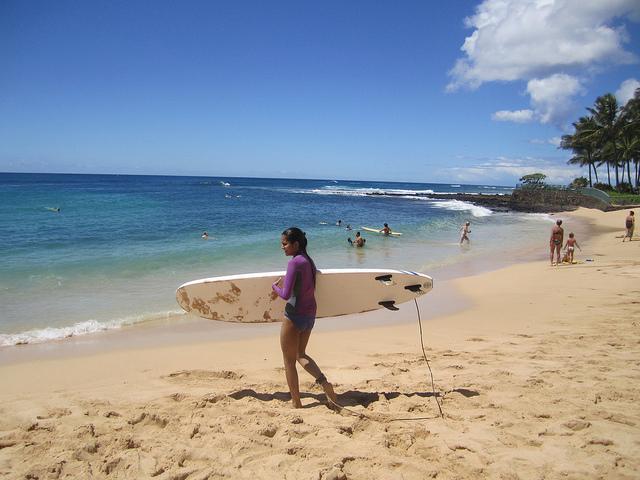Is that a man or a woman?
Be succinct. Woman. Is this an old surfboard?
Write a very short answer. Yes. Is the surfboard strap attached to the surfer's ankle?
Answer briefly. Yes. How many people in the photo?
Quick response, please. 10. Why is the board tied to a leash?
Give a very brief answer. Safety. How many people are carrying surfboards?
Short answer required. 1. Is the girl trying to catch something?
Answer briefly. No. Who is going into the water?
Concise answer only. Girl. Is she going to fly a kite?
Keep it brief. No. How many surfboards?
Keep it brief. 2. How many jet skis do you see?
Give a very brief answer. 0. Are these people in the water?
Answer briefly. Yes. Is this lady good enough to surf?
Be succinct. Yes. 